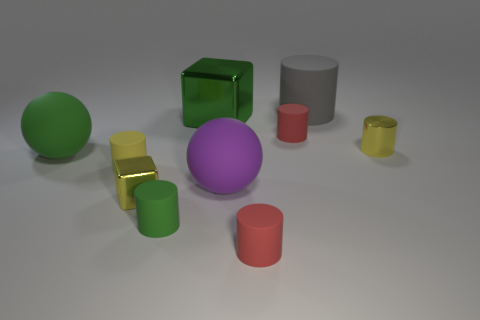Are there the same number of big purple objects left of the big purple ball and yellow rubber cylinders?
Your answer should be compact. No. What is the size of the gray thing that is the same shape as the tiny green matte object?
Keep it short and to the point. Large. Do the purple rubber thing and the large rubber thing that is on the left side of the small green thing have the same shape?
Provide a succinct answer. Yes. How big is the purple matte sphere to the left of the tiny red thing that is in front of the large green matte object?
Provide a succinct answer. Large. Is the number of big metallic things that are left of the tiny green matte thing the same as the number of cylinders to the left of the big cylinder?
Your answer should be compact. No. There is a shiny object that is the same shape as the gray rubber object; what is its color?
Provide a short and direct response. Yellow. How many small matte cylinders have the same color as the tiny cube?
Keep it short and to the point. 1. There is a big green object that is in front of the large green metal cube; is it the same shape as the purple thing?
Provide a succinct answer. Yes. There is a small red thing that is to the left of the tiny red thing that is behind the tiny yellow object on the right side of the large green metal cube; what is its shape?
Give a very brief answer. Cylinder. The gray object has what size?
Your answer should be compact. Large. 